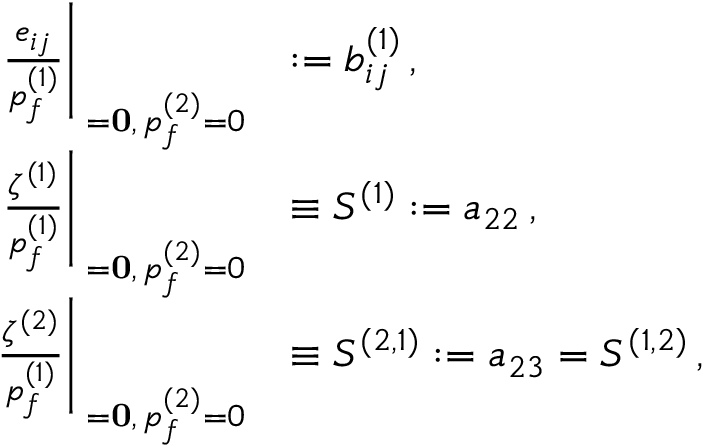Convert formula to latex. <formula><loc_0><loc_0><loc_500><loc_500>\begin{array} { r l } { \frac { e _ { i j } } { p _ { f } ^ { ( 1 ) } } \right | _ { { \sigma = 0 } , \, p _ { f } ^ { ( 2 ) } = 0 } } & { \colon = b _ { i j } ^ { ( 1 ) } \, , } \\ { \frac { \zeta ^ { ( 1 ) } } { p _ { f } ^ { ( 1 ) } } \right | _ { { \sigma = 0 } , \, p _ { f } ^ { ( 2 ) } = 0 } } & { \equiv S ^ { ( 1 ) } \colon = a _ { 2 2 } \, , } \\ { \frac { \zeta ^ { ( 2 ) } } { p _ { f } ^ { ( 1 ) } } \right | _ { { \sigma = 0 } , \, p _ { f } ^ { ( 2 ) } = 0 } } & { \equiv S ^ { ( 2 , 1 ) } \colon = a _ { 2 3 } = S ^ { ( 1 , 2 ) } \, , } \end{array}</formula> 